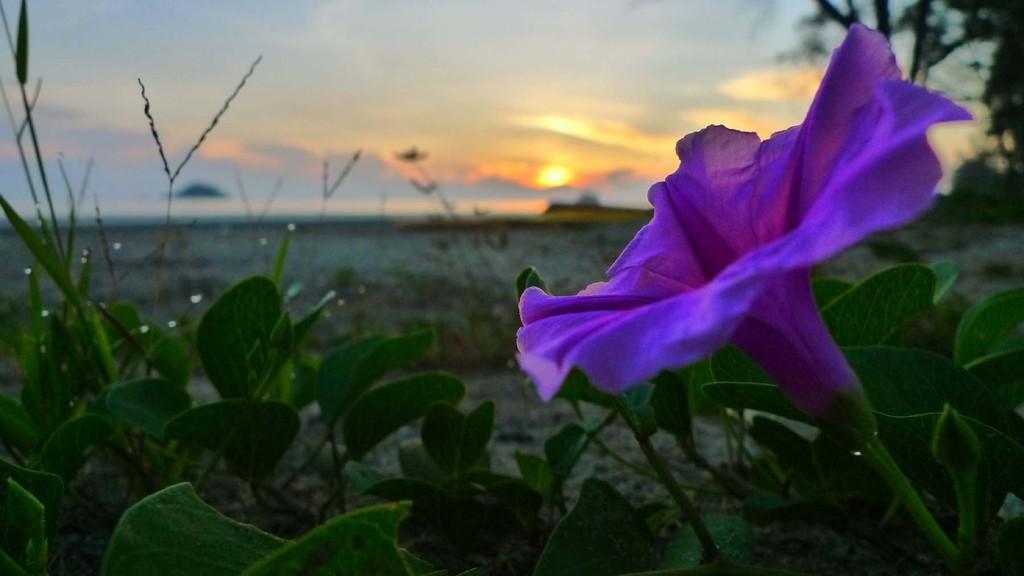Please provide a concise description of this image. In this image we can see flower, plants, ground, sky, clouds and sun. 